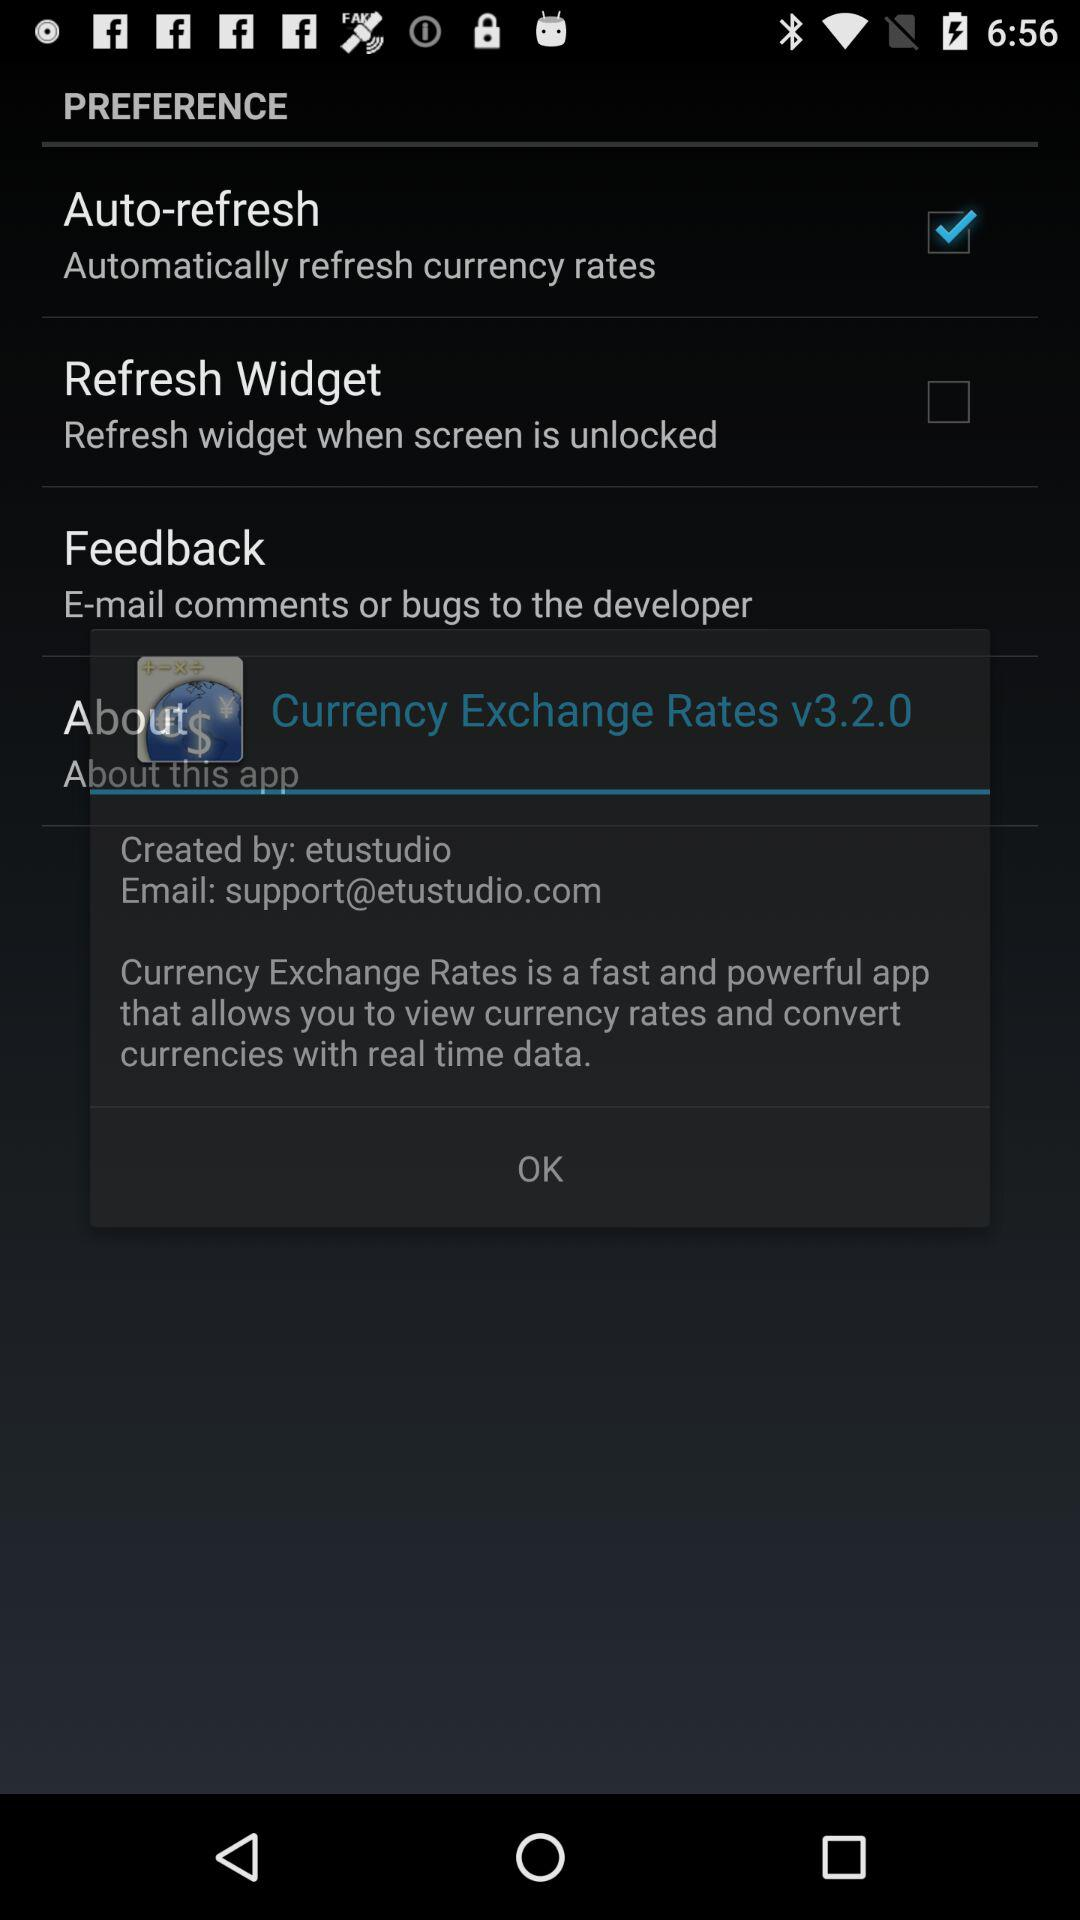How much is the EUR worth in USD?
Answer the question using a single word or phrase. 1.0693 